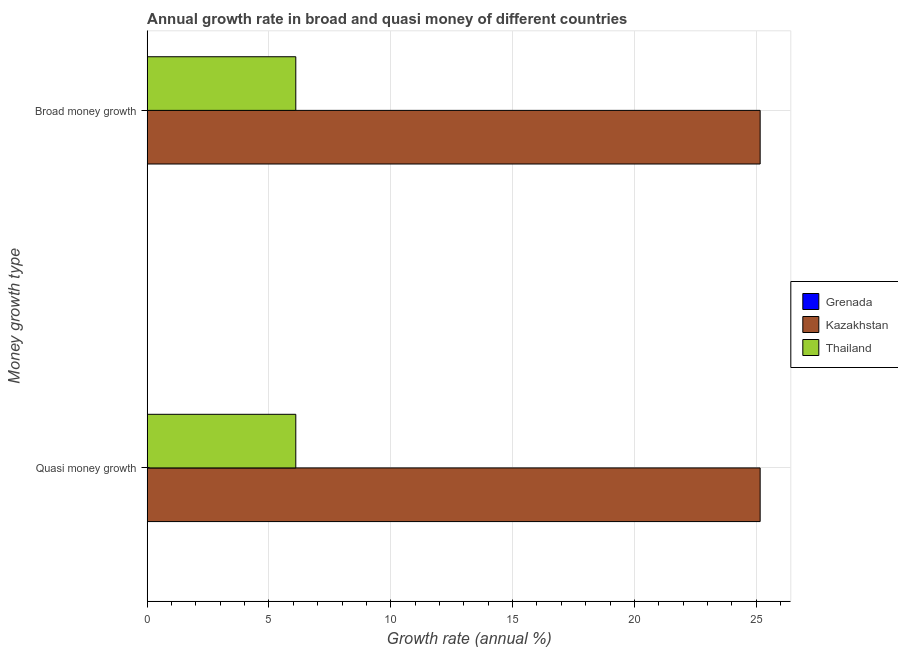Are the number of bars on each tick of the Y-axis equal?
Provide a short and direct response. Yes. How many bars are there on the 2nd tick from the top?
Make the answer very short. 2. How many bars are there on the 2nd tick from the bottom?
Make the answer very short. 2. What is the label of the 1st group of bars from the top?
Give a very brief answer. Broad money growth. What is the annual growth rate in broad money in Kazakhstan?
Give a very brief answer. 25.16. Across all countries, what is the maximum annual growth rate in broad money?
Your answer should be compact. 25.16. Across all countries, what is the minimum annual growth rate in quasi money?
Offer a terse response. 0. In which country was the annual growth rate in quasi money maximum?
Make the answer very short. Kazakhstan. What is the total annual growth rate in broad money in the graph?
Offer a very short reply. 31.27. What is the difference between the annual growth rate in broad money in Kazakhstan and that in Thailand?
Offer a very short reply. 19.06. What is the difference between the annual growth rate in broad money in Kazakhstan and the annual growth rate in quasi money in Grenada?
Provide a succinct answer. 25.16. What is the average annual growth rate in broad money per country?
Your answer should be very brief. 10.42. What is the difference between the annual growth rate in quasi money and annual growth rate in broad money in Kazakhstan?
Provide a succinct answer. 0. In how many countries, is the annual growth rate in broad money greater than 4 %?
Give a very brief answer. 2. What is the ratio of the annual growth rate in quasi money in Thailand to that in Kazakhstan?
Your answer should be compact. 0.24. How many bars are there?
Ensure brevity in your answer.  4. What is the difference between two consecutive major ticks on the X-axis?
Give a very brief answer. 5. Are the values on the major ticks of X-axis written in scientific E-notation?
Ensure brevity in your answer.  No. Does the graph contain grids?
Your answer should be very brief. Yes. Where does the legend appear in the graph?
Give a very brief answer. Center right. How many legend labels are there?
Offer a terse response. 3. What is the title of the graph?
Offer a terse response. Annual growth rate in broad and quasi money of different countries. Does "Korea (Democratic)" appear as one of the legend labels in the graph?
Your answer should be compact. No. What is the label or title of the X-axis?
Provide a short and direct response. Growth rate (annual %). What is the label or title of the Y-axis?
Provide a short and direct response. Money growth type. What is the Growth rate (annual %) of Grenada in Quasi money growth?
Ensure brevity in your answer.  0. What is the Growth rate (annual %) in Kazakhstan in Quasi money growth?
Give a very brief answer. 25.16. What is the Growth rate (annual %) of Thailand in Quasi money growth?
Provide a short and direct response. 6.1. What is the Growth rate (annual %) of Kazakhstan in Broad money growth?
Give a very brief answer. 25.16. What is the Growth rate (annual %) in Thailand in Broad money growth?
Provide a short and direct response. 6.1. Across all Money growth type, what is the maximum Growth rate (annual %) in Kazakhstan?
Make the answer very short. 25.16. Across all Money growth type, what is the maximum Growth rate (annual %) of Thailand?
Offer a very short reply. 6.1. Across all Money growth type, what is the minimum Growth rate (annual %) in Kazakhstan?
Offer a terse response. 25.16. Across all Money growth type, what is the minimum Growth rate (annual %) in Thailand?
Your answer should be compact. 6.1. What is the total Growth rate (annual %) in Grenada in the graph?
Your answer should be very brief. 0. What is the total Growth rate (annual %) of Kazakhstan in the graph?
Your answer should be very brief. 50.33. What is the total Growth rate (annual %) of Thailand in the graph?
Your answer should be very brief. 12.2. What is the difference between the Growth rate (annual %) in Kazakhstan in Quasi money growth and the Growth rate (annual %) in Thailand in Broad money growth?
Your answer should be very brief. 19.06. What is the average Growth rate (annual %) in Grenada per Money growth type?
Your answer should be very brief. 0. What is the average Growth rate (annual %) of Kazakhstan per Money growth type?
Your answer should be compact. 25.16. What is the average Growth rate (annual %) in Thailand per Money growth type?
Keep it short and to the point. 6.1. What is the difference between the Growth rate (annual %) in Kazakhstan and Growth rate (annual %) in Thailand in Quasi money growth?
Keep it short and to the point. 19.06. What is the difference between the Growth rate (annual %) in Kazakhstan and Growth rate (annual %) in Thailand in Broad money growth?
Offer a terse response. 19.06. What is the ratio of the Growth rate (annual %) in Kazakhstan in Quasi money growth to that in Broad money growth?
Give a very brief answer. 1. What is the difference between the highest and the lowest Growth rate (annual %) of Kazakhstan?
Your answer should be compact. 0. What is the difference between the highest and the lowest Growth rate (annual %) in Thailand?
Ensure brevity in your answer.  0. 